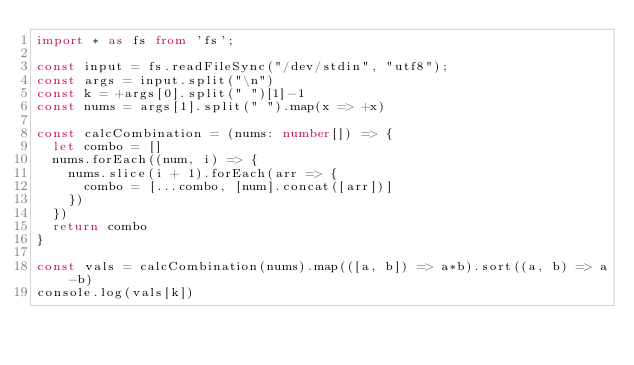Convert code to text. <code><loc_0><loc_0><loc_500><loc_500><_TypeScript_>import * as fs from 'fs';

const input = fs.readFileSync("/dev/stdin", "utf8");
const args = input.split("\n")
const k = +args[0].split(" ")[1]-1
const nums = args[1].split(" ").map(x => +x)

const calcCombination = (nums: number[]) => {
  let combo = []
  nums.forEach((num, i) => {
    nums.slice(i + 1).forEach(arr => {
      combo = [...combo, [num].concat([arr])]
    })
  })
  return combo
}

const vals = calcCombination(nums).map(([a, b]) => a*b).sort((a, b) => a-b)
console.log(vals[k])
</code> 